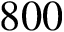Convert formula to latex. <formula><loc_0><loc_0><loc_500><loc_500>8 0 0</formula> 